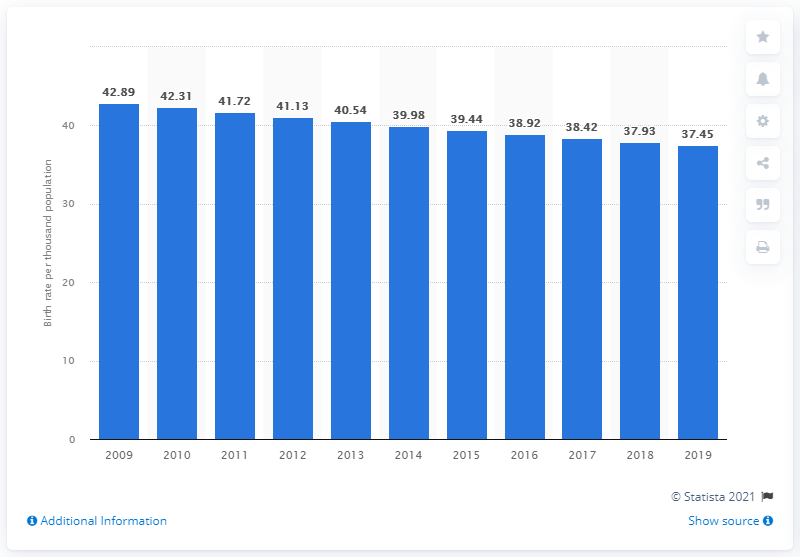Mention a couple of crucial points in this snapshot. Based on the most recent data, the crude birth rate in Burkina Faso in 2019 was 37.45. 